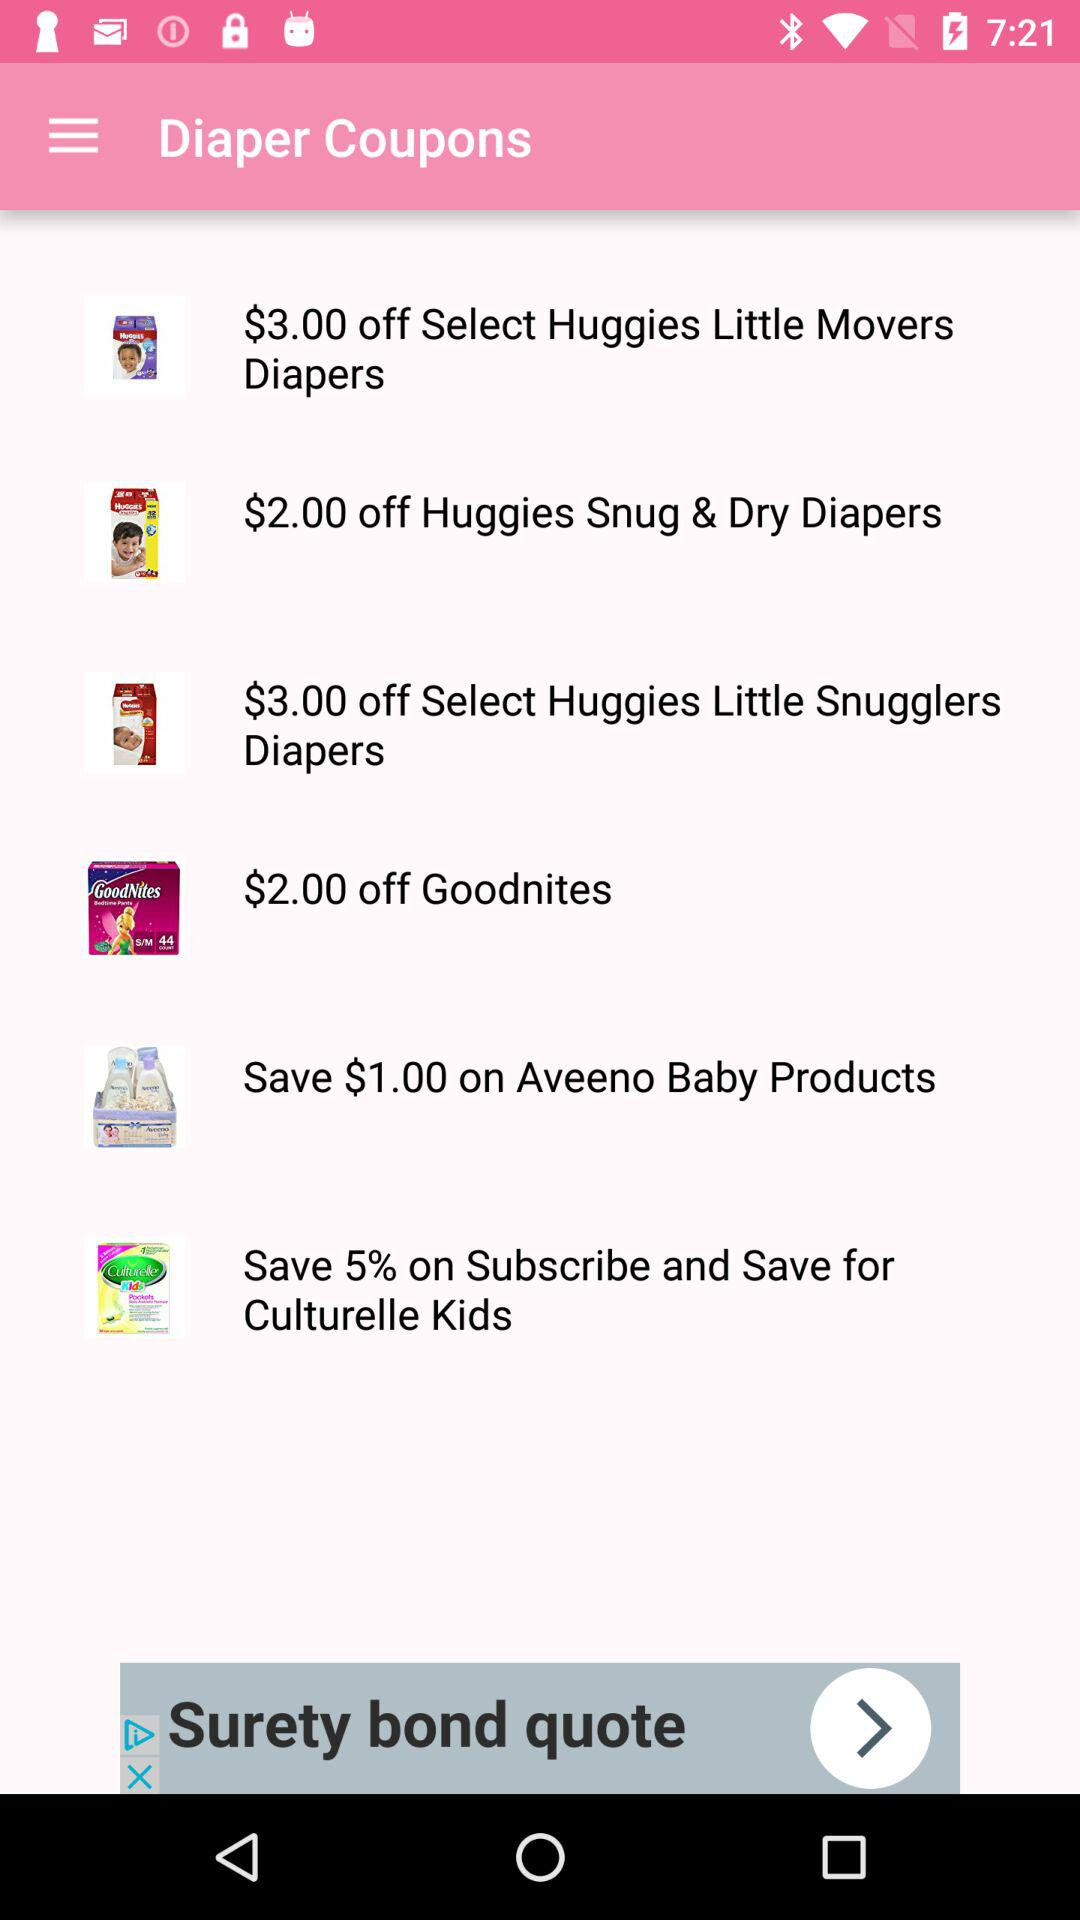What amount is off on "Huggies Little Movers Diapers"? The amount is $3. 